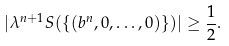<formula> <loc_0><loc_0><loc_500><loc_500>| \lambda ^ { n + 1 } S ( \{ ( b ^ { n } , 0 , \dots , 0 ) \} ) | \geq \frac { 1 } { 2 } .</formula> 